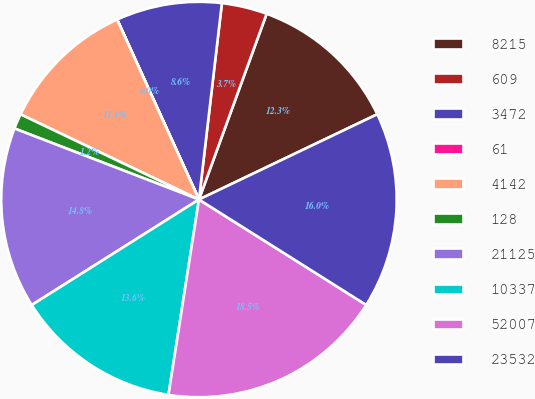Convert chart to OTSL. <chart><loc_0><loc_0><loc_500><loc_500><pie_chart><fcel>8215<fcel>609<fcel>3472<fcel>61<fcel>4142<fcel>128<fcel>21125<fcel>10337<fcel>52007<fcel>23532<nl><fcel>12.34%<fcel>3.71%<fcel>8.64%<fcel>0.01%<fcel>11.11%<fcel>1.24%<fcel>14.81%<fcel>13.58%<fcel>18.51%<fcel>16.05%<nl></chart> 